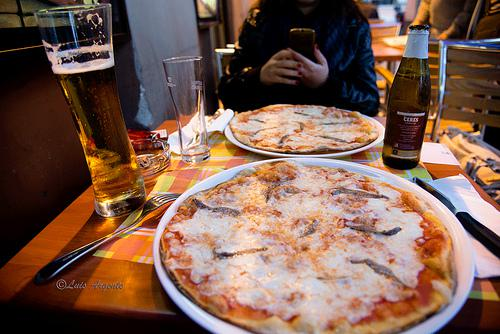Question: why are the plates so big?
Choices:
A. They are enlarged.
B. To hold the whole pizza.
C. To put a bunch of food on.
D. They are extra large.
Answer with the letter. Answer: B Question: when was this meal eaten?
Choices:
A. For lunch.
B. For a snack.
C. For breakfast.
D. Dinner.
Answer with the letter. Answer: D Question: who is at the other side of the table?
Choices:
A. A person on a laptop.
B. The woman.
C. The person with the phone.
D. The child.
Answer with the letter. Answer: C Question: what eating utensil is upside down?
Choices:
A. Spoon.
B. Knife.
C. Spork.
D. Fork.
Answer with the letter. Answer: D Question: what is in the shorter glass?
Choices:
A. Water.
B. Nothing.
C. Tea.
D. Coffee.
Answer with the letter. Answer: B 